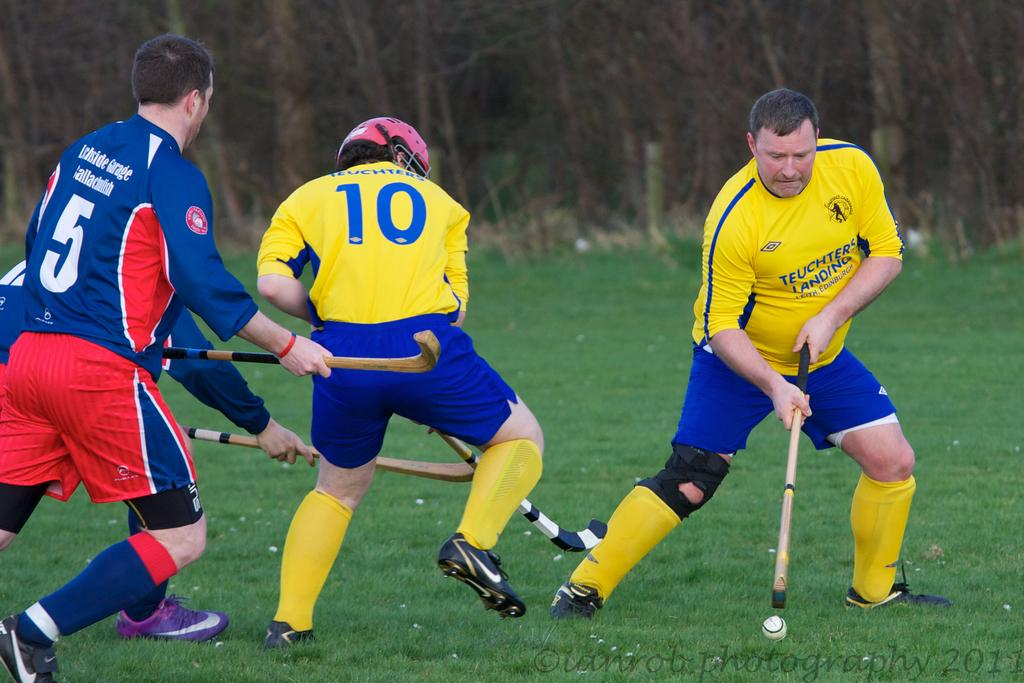What are the men in the image doing? The men are standing and holding hockey sticks in the image. What is on the ground near the men? There is a ball on the ground in the image. What type of surface is the ball on? The ground is covered with grass in the image. What type of apparel is the goat wearing in the image? There is no goat present in the image, so it is not possible to determine what type of apparel it might be wearing. 